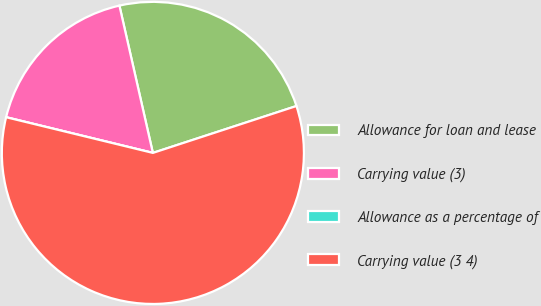Convert chart. <chart><loc_0><loc_0><loc_500><loc_500><pie_chart><fcel>Allowance for loan and lease<fcel>Carrying value (3)<fcel>Allowance as a percentage of<fcel>Carrying value (3 4)<nl><fcel>23.53%<fcel>17.65%<fcel>0.0%<fcel>58.82%<nl></chart> 